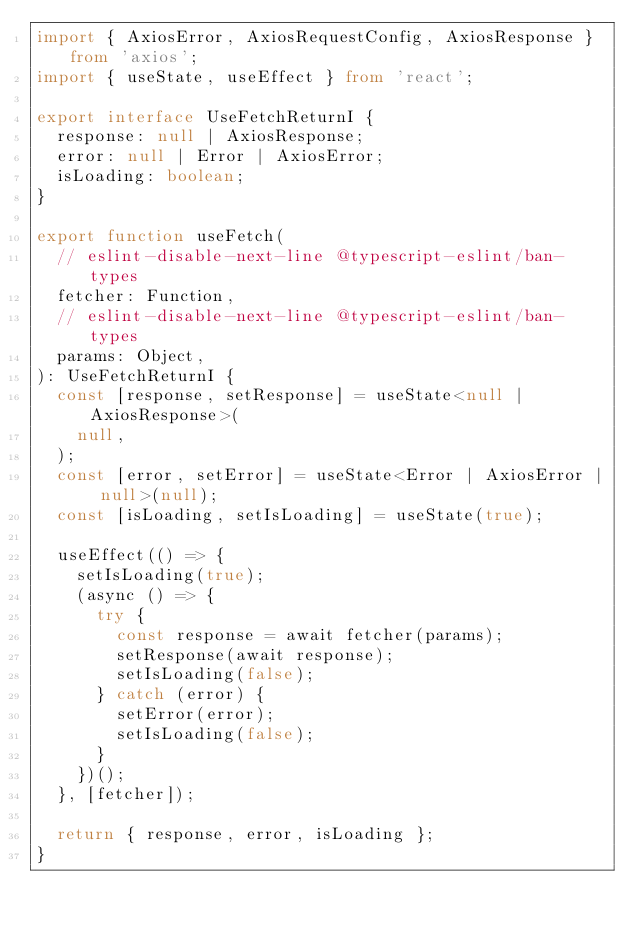Convert code to text. <code><loc_0><loc_0><loc_500><loc_500><_TypeScript_>import { AxiosError, AxiosRequestConfig, AxiosResponse } from 'axios';
import { useState, useEffect } from 'react';

export interface UseFetchReturnI {
  response: null | AxiosResponse;
  error: null | Error | AxiosError;
  isLoading: boolean;
}

export function useFetch(
  // eslint-disable-next-line @typescript-eslint/ban-types
  fetcher: Function,
  // eslint-disable-next-line @typescript-eslint/ban-types
  params: Object,
): UseFetchReturnI {
  const [response, setResponse] = useState<null | AxiosResponse>(
    null,
  );
  const [error, setError] = useState<Error | AxiosError | null>(null);
  const [isLoading, setIsLoading] = useState(true);

  useEffect(() => {
    setIsLoading(true);
    (async () => {
      try {
        const response = await fetcher(params);
        setResponse(await response);
        setIsLoading(false);
      } catch (error) {
        setError(error);
        setIsLoading(false);
      }
    })();
  }, [fetcher]);

  return { response, error, isLoading };
}
</code> 